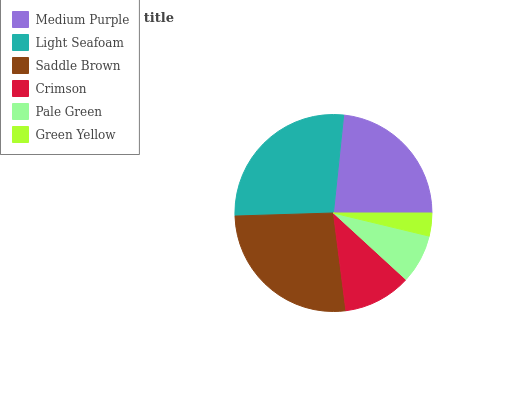Is Green Yellow the minimum?
Answer yes or no. Yes. Is Light Seafoam the maximum?
Answer yes or no. Yes. Is Saddle Brown the minimum?
Answer yes or no. No. Is Saddle Brown the maximum?
Answer yes or no. No. Is Light Seafoam greater than Saddle Brown?
Answer yes or no. Yes. Is Saddle Brown less than Light Seafoam?
Answer yes or no. Yes. Is Saddle Brown greater than Light Seafoam?
Answer yes or no. No. Is Light Seafoam less than Saddle Brown?
Answer yes or no. No. Is Medium Purple the high median?
Answer yes or no. Yes. Is Crimson the low median?
Answer yes or no. Yes. Is Saddle Brown the high median?
Answer yes or no. No. Is Light Seafoam the low median?
Answer yes or no. No. 